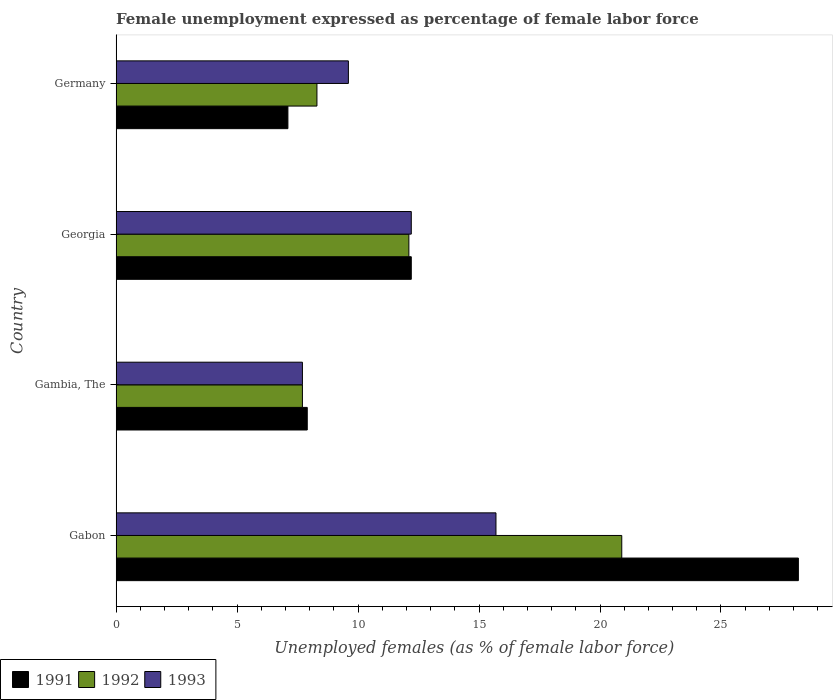How many different coloured bars are there?
Your response must be concise. 3. Are the number of bars per tick equal to the number of legend labels?
Your answer should be very brief. Yes. Are the number of bars on each tick of the Y-axis equal?
Provide a succinct answer. Yes. How many bars are there on the 4th tick from the top?
Your answer should be compact. 3. What is the label of the 4th group of bars from the top?
Your answer should be very brief. Gabon. In how many cases, is the number of bars for a given country not equal to the number of legend labels?
Provide a succinct answer. 0. What is the unemployment in females in in 1991 in Georgia?
Your answer should be very brief. 12.2. Across all countries, what is the maximum unemployment in females in in 1991?
Provide a short and direct response. 28.2. Across all countries, what is the minimum unemployment in females in in 1992?
Keep it short and to the point. 7.7. In which country was the unemployment in females in in 1991 maximum?
Keep it short and to the point. Gabon. In which country was the unemployment in females in in 1993 minimum?
Make the answer very short. Gambia, The. What is the difference between the unemployment in females in in 1991 in Georgia and that in Germany?
Give a very brief answer. 5.1. What is the difference between the unemployment in females in in 1992 in Gambia, The and the unemployment in females in in 1991 in Georgia?
Your answer should be compact. -4.5. What is the average unemployment in females in in 1993 per country?
Make the answer very short. 11.3. What is the difference between the unemployment in females in in 1992 and unemployment in females in in 1991 in Gambia, The?
Your answer should be compact. -0.2. In how many countries, is the unemployment in females in in 1991 greater than 6 %?
Your answer should be very brief. 4. What is the ratio of the unemployment in females in in 1991 in Gabon to that in Georgia?
Offer a very short reply. 2.31. Is the difference between the unemployment in females in in 1992 in Gambia, The and Germany greater than the difference between the unemployment in females in in 1991 in Gambia, The and Germany?
Your response must be concise. No. What is the difference between the highest and the second highest unemployment in females in in 1991?
Your answer should be very brief. 16. What is the difference between the highest and the lowest unemployment in females in in 1991?
Your answer should be compact. 21.1. Is the sum of the unemployment in females in in 1993 in Gabon and Georgia greater than the maximum unemployment in females in in 1992 across all countries?
Your answer should be very brief. Yes. What does the 3rd bar from the top in Germany represents?
Provide a succinct answer. 1991. How many bars are there?
Your answer should be very brief. 12. Are all the bars in the graph horizontal?
Give a very brief answer. Yes. How many countries are there in the graph?
Keep it short and to the point. 4. What is the difference between two consecutive major ticks on the X-axis?
Make the answer very short. 5. Are the values on the major ticks of X-axis written in scientific E-notation?
Provide a succinct answer. No. Does the graph contain grids?
Your response must be concise. No. Where does the legend appear in the graph?
Your answer should be very brief. Bottom left. How many legend labels are there?
Provide a short and direct response. 3. How are the legend labels stacked?
Give a very brief answer. Horizontal. What is the title of the graph?
Keep it short and to the point. Female unemployment expressed as percentage of female labor force. What is the label or title of the X-axis?
Keep it short and to the point. Unemployed females (as % of female labor force). What is the Unemployed females (as % of female labor force) of 1991 in Gabon?
Your answer should be very brief. 28.2. What is the Unemployed females (as % of female labor force) of 1992 in Gabon?
Keep it short and to the point. 20.9. What is the Unemployed females (as % of female labor force) of 1993 in Gabon?
Give a very brief answer. 15.7. What is the Unemployed females (as % of female labor force) in 1991 in Gambia, The?
Provide a short and direct response. 7.9. What is the Unemployed females (as % of female labor force) in 1992 in Gambia, The?
Offer a terse response. 7.7. What is the Unemployed females (as % of female labor force) in 1993 in Gambia, The?
Ensure brevity in your answer.  7.7. What is the Unemployed females (as % of female labor force) of 1991 in Georgia?
Provide a succinct answer. 12.2. What is the Unemployed females (as % of female labor force) of 1992 in Georgia?
Your answer should be compact. 12.1. What is the Unemployed females (as % of female labor force) in 1993 in Georgia?
Ensure brevity in your answer.  12.2. What is the Unemployed females (as % of female labor force) of 1991 in Germany?
Your response must be concise. 7.1. What is the Unemployed females (as % of female labor force) in 1992 in Germany?
Give a very brief answer. 8.3. What is the Unemployed females (as % of female labor force) of 1993 in Germany?
Your answer should be compact. 9.6. Across all countries, what is the maximum Unemployed females (as % of female labor force) of 1991?
Offer a terse response. 28.2. Across all countries, what is the maximum Unemployed females (as % of female labor force) in 1992?
Provide a short and direct response. 20.9. Across all countries, what is the maximum Unemployed females (as % of female labor force) of 1993?
Offer a very short reply. 15.7. Across all countries, what is the minimum Unemployed females (as % of female labor force) in 1991?
Offer a very short reply. 7.1. Across all countries, what is the minimum Unemployed females (as % of female labor force) in 1992?
Make the answer very short. 7.7. Across all countries, what is the minimum Unemployed females (as % of female labor force) of 1993?
Your answer should be very brief. 7.7. What is the total Unemployed females (as % of female labor force) in 1991 in the graph?
Ensure brevity in your answer.  55.4. What is the total Unemployed females (as % of female labor force) of 1993 in the graph?
Provide a succinct answer. 45.2. What is the difference between the Unemployed females (as % of female labor force) in 1991 in Gabon and that in Gambia, The?
Offer a terse response. 20.3. What is the difference between the Unemployed females (as % of female labor force) in 1992 in Gabon and that in Gambia, The?
Provide a short and direct response. 13.2. What is the difference between the Unemployed females (as % of female labor force) of 1992 in Gabon and that in Georgia?
Keep it short and to the point. 8.8. What is the difference between the Unemployed females (as % of female labor force) of 1993 in Gabon and that in Georgia?
Ensure brevity in your answer.  3.5. What is the difference between the Unemployed females (as % of female labor force) in 1991 in Gabon and that in Germany?
Your response must be concise. 21.1. What is the difference between the Unemployed females (as % of female labor force) of 1993 in Gabon and that in Germany?
Offer a very short reply. 6.1. What is the difference between the Unemployed females (as % of female labor force) in 1992 in Gambia, The and that in Georgia?
Ensure brevity in your answer.  -4.4. What is the difference between the Unemployed females (as % of female labor force) of 1991 in Gambia, The and that in Germany?
Provide a short and direct response. 0.8. What is the difference between the Unemployed females (as % of female labor force) of 1993 in Gambia, The and that in Germany?
Provide a short and direct response. -1.9. What is the difference between the Unemployed females (as % of female labor force) of 1992 in Georgia and that in Germany?
Offer a terse response. 3.8. What is the difference between the Unemployed females (as % of female labor force) in 1992 in Gabon and the Unemployed females (as % of female labor force) in 1993 in Gambia, The?
Provide a succinct answer. 13.2. What is the difference between the Unemployed females (as % of female labor force) in 1991 in Gabon and the Unemployed females (as % of female labor force) in 1993 in Georgia?
Offer a terse response. 16. What is the difference between the Unemployed females (as % of female labor force) in 1992 in Gabon and the Unemployed females (as % of female labor force) in 1993 in Georgia?
Make the answer very short. 8.7. What is the difference between the Unemployed females (as % of female labor force) of 1991 in Gabon and the Unemployed females (as % of female labor force) of 1993 in Germany?
Provide a short and direct response. 18.6. What is the difference between the Unemployed females (as % of female labor force) of 1992 in Gabon and the Unemployed females (as % of female labor force) of 1993 in Germany?
Your response must be concise. 11.3. What is the difference between the Unemployed females (as % of female labor force) of 1991 in Gambia, The and the Unemployed females (as % of female labor force) of 1992 in Georgia?
Offer a very short reply. -4.2. What is the difference between the Unemployed females (as % of female labor force) in 1991 in Gambia, The and the Unemployed females (as % of female labor force) in 1993 in Germany?
Make the answer very short. -1.7. What is the average Unemployed females (as % of female labor force) of 1991 per country?
Offer a very short reply. 13.85. What is the average Unemployed females (as % of female labor force) of 1992 per country?
Give a very brief answer. 12.25. What is the difference between the Unemployed females (as % of female labor force) of 1991 and Unemployed females (as % of female labor force) of 1992 in Gabon?
Your answer should be very brief. 7.3. What is the difference between the Unemployed females (as % of female labor force) of 1991 and Unemployed females (as % of female labor force) of 1993 in Gabon?
Your answer should be very brief. 12.5. What is the difference between the Unemployed females (as % of female labor force) in 1992 and Unemployed females (as % of female labor force) in 1993 in Gabon?
Give a very brief answer. 5.2. What is the difference between the Unemployed females (as % of female labor force) of 1991 and Unemployed females (as % of female labor force) of 1993 in Gambia, The?
Your answer should be very brief. 0.2. What is the difference between the Unemployed females (as % of female labor force) in 1992 and Unemployed females (as % of female labor force) in 1993 in Gambia, The?
Your answer should be compact. 0. What is the difference between the Unemployed females (as % of female labor force) of 1991 and Unemployed females (as % of female labor force) of 1992 in Georgia?
Provide a succinct answer. 0.1. What is the difference between the Unemployed females (as % of female labor force) of 1991 and Unemployed females (as % of female labor force) of 1993 in Georgia?
Your answer should be very brief. 0. What is the difference between the Unemployed females (as % of female labor force) in 1992 and Unemployed females (as % of female labor force) in 1993 in Georgia?
Ensure brevity in your answer.  -0.1. What is the difference between the Unemployed females (as % of female labor force) of 1991 and Unemployed females (as % of female labor force) of 1993 in Germany?
Keep it short and to the point. -2.5. What is the ratio of the Unemployed females (as % of female labor force) in 1991 in Gabon to that in Gambia, The?
Ensure brevity in your answer.  3.57. What is the ratio of the Unemployed females (as % of female labor force) in 1992 in Gabon to that in Gambia, The?
Provide a succinct answer. 2.71. What is the ratio of the Unemployed females (as % of female labor force) of 1993 in Gabon to that in Gambia, The?
Give a very brief answer. 2.04. What is the ratio of the Unemployed females (as % of female labor force) in 1991 in Gabon to that in Georgia?
Provide a short and direct response. 2.31. What is the ratio of the Unemployed females (as % of female labor force) in 1992 in Gabon to that in Georgia?
Keep it short and to the point. 1.73. What is the ratio of the Unemployed females (as % of female labor force) in 1993 in Gabon to that in Georgia?
Offer a very short reply. 1.29. What is the ratio of the Unemployed females (as % of female labor force) in 1991 in Gabon to that in Germany?
Offer a very short reply. 3.97. What is the ratio of the Unemployed females (as % of female labor force) in 1992 in Gabon to that in Germany?
Make the answer very short. 2.52. What is the ratio of the Unemployed females (as % of female labor force) of 1993 in Gabon to that in Germany?
Make the answer very short. 1.64. What is the ratio of the Unemployed females (as % of female labor force) in 1991 in Gambia, The to that in Georgia?
Give a very brief answer. 0.65. What is the ratio of the Unemployed females (as % of female labor force) of 1992 in Gambia, The to that in Georgia?
Provide a succinct answer. 0.64. What is the ratio of the Unemployed females (as % of female labor force) in 1993 in Gambia, The to that in Georgia?
Ensure brevity in your answer.  0.63. What is the ratio of the Unemployed females (as % of female labor force) in 1991 in Gambia, The to that in Germany?
Give a very brief answer. 1.11. What is the ratio of the Unemployed females (as % of female labor force) of 1992 in Gambia, The to that in Germany?
Your response must be concise. 0.93. What is the ratio of the Unemployed females (as % of female labor force) of 1993 in Gambia, The to that in Germany?
Your answer should be compact. 0.8. What is the ratio of the Unemployed females (as % of female labor force) of 1991 in Georgia to that in Germany?
Provide a succinct answer. 1.72. What is the ratio of the Unemployed females (as % of female labor force) in 1992 in Georgia to that in Germany?
Offer a terse response. 1.46. What is the ratio of the Unemployed females (as % of female labor force) of 1993 in Georgia to that in Germany?
Your answer should be compact. 1.27. What is the difference between the highest and the second highest Unemployed females (as % of female labor force) in 1991?
Make the answer very short. 16. What is the difference between the highest and the second highest Unemployed females (as % of female labor force) of 1993?
Your answer should be very brief. 3.5. What is the difference between the highest and the lowest Unemployed females (as % of female labor force) in 1991?
Your answer should be very brief. 21.1. What is the difference between the highest and the lowest Unemployed females (as % of female labor force) in 1993?
Your answer should be compact. 8. 